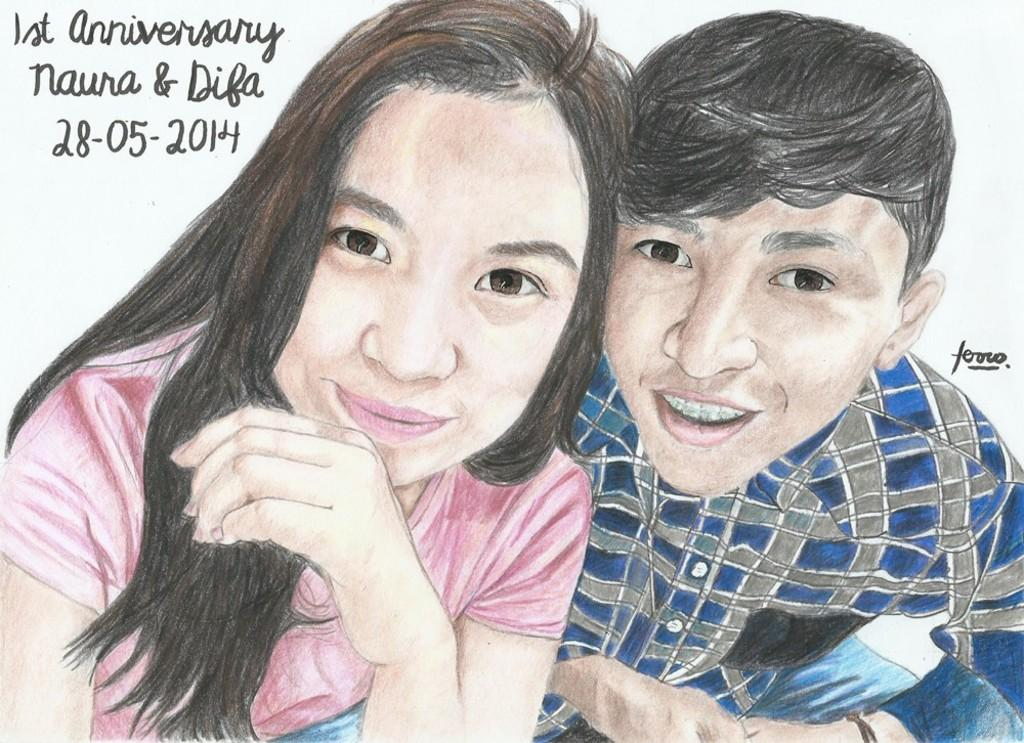What style is the image created in? The image is a pencil sketch. What subjects are depicted in the sketch? The sketch depicts a man and woman. What expressions do the man and woman have in the sketch? The man and woman are smiling. What else can be seen in the image besides the sketch? There are letters visible in the image. What type of wine is being served in the image? There is no wine present in the image; it is a pencil sketch of a man and woman. How many pizzas can be seen in the image? There are no pizzas present in the image. 